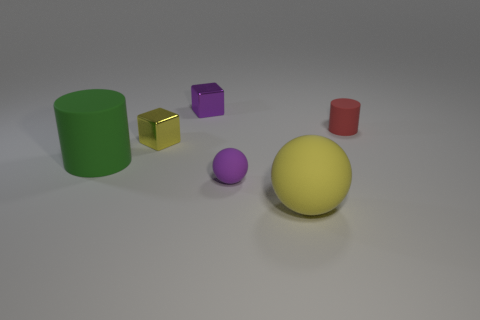Is the color of the sphere that is to the right of the purple matte ball the same as the tiny shiny thing that is in front of the tiny purple block?
Give a very brief answer. Yes. The green matte thing is what size?
Your answer should be compact. Large. There is a matte object that is right of the big sphere; what size is it?
Your answer should be very brief. Small. What is the shape of the thing that is both in front of the tiny yellow thing and on the left side of the purple sphere?
Provide a succinct answer. Cylinder. What number of other objects are there of the same shape as the yellow metallic object?
Your answer should be compact. 1. What color is the other rubber thing that is the same size as the red object?
Your response must be concise. Purple. How many objects are either large rubber balls or large yellow metallic spheres?
Offer a terse response. 1. There is a large matte cylinder; are there any large things to the right of it?
Your answer should be very brief. Yes. Is there a brown ball made of the same material as the tiny cylinder?
Provide a short and direct response. No. How many balls are small red rubber objects or tiny metallic things?
Offer a terse response. 0. 